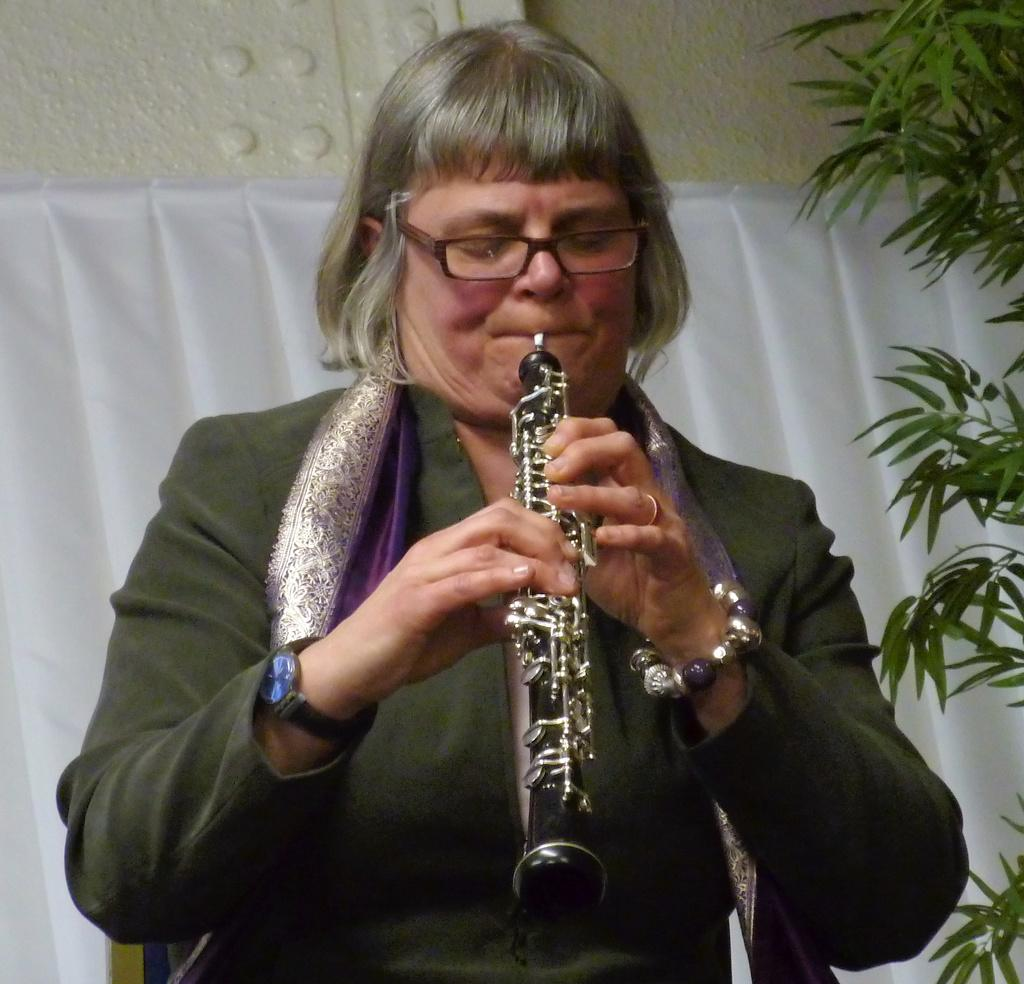What is the main subject of the image? There is a woman in the image. What is the woman doing in the image? The woman is playing a musical instrument. What can be seen in the background of the image? There is a white curtain in the background of the image. What type of vegetation is visible in the image? There are leaves on the right side of the image. What is the aftermath of the destruction caused by the team in the image? There is no destruction, team, or aftermath present in the image; it features a woman playing a musical instrument with a white curtain in the background and leaves on the right side. 